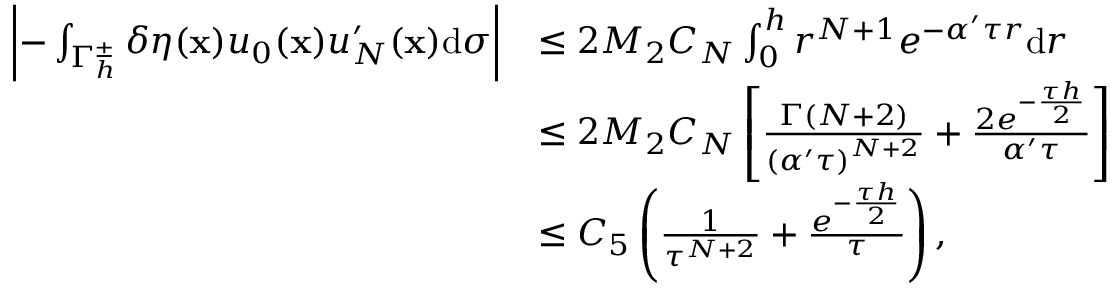<formula> <loc_0><loc_0><loc_500><loc_500>\begin{array} { r l } { \left | - \int _ { { \Gamma _ { h } ^ { \pm } } } \delta \eta ( \mathbf x ) { { u _ { 0 } } ( \mathbf x ) } u _ { N } ^ { \prime } ( \mathbf x ) \mathrm d \sigma \right | } & { \leq 2 M _ { 2 } C _ { N } \int _ { 0 } ^ { h } { { r ^ { N + 1 } } { e ^ { - \alpha ^ { \prime } \tau r } } \mathrm d r } } \\ & { \leq 2 M _ { 2 } C _ { N } \left [ { \frac { \Gamma ( N + 2 ) } { { { ( \alpha ^ { \prime } \tau ) } ^ { N + 2 } } } } + { \frac { 2 { e ^ { - { \frac { \tau h } { 2 } } } } } { \alpha ^ { \prime } \tau } } \right ] } \\ & { \leq { C _ { 5 } } \left ( { \frac { 1 } { { \tau ^ { N + 2 } } } } + { \frac { { e ^ { - { \frac { \tau h } { 2 } } } } } { \tau } } \right ) , } \end{array}</formula> 